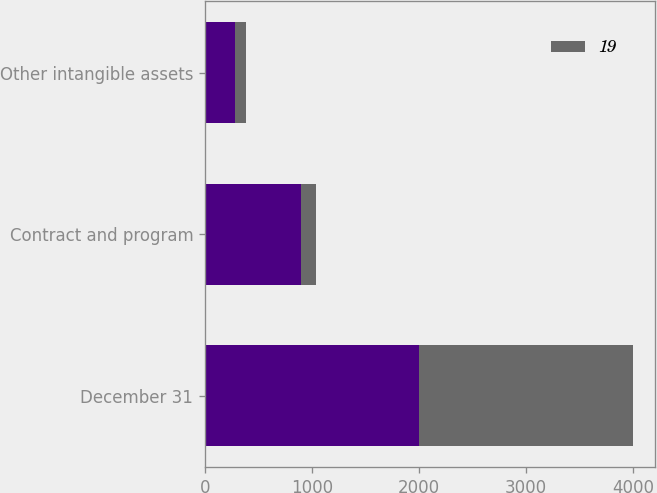<chart> <loc_0><loc_0><loc_500><loc_500><stacked_bar_chart><ecel><fcel>December 31<fcel>Contract and program<fcel>Other intangible assets<nl><fcel>nan<fcel>2003<fcel>900<fcel>278<nl><fcel>19<fcel>2003<fcel>141<fcel>103<nl></chart> 